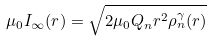Convert formula to latex. <formula><loc_0><loc_0><loc_500><loc_500>\mu _ { 0 } I _ { \infty } ( r ) = \sqrt { 2 \mu _ { 0 } Q _ { n } r ^ { 2 } \rho _ { n } ^ { \gamma } ( r ) }</formula> 